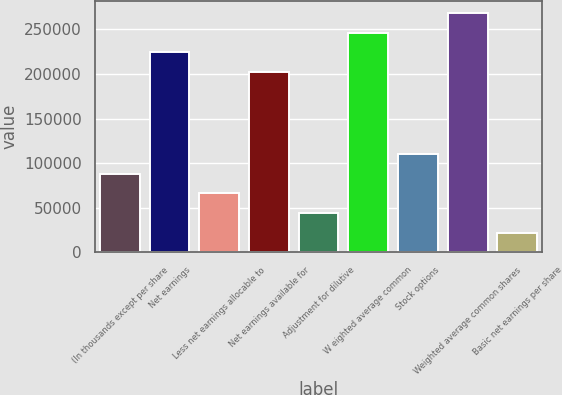Convert chart to OTSL. <chart><loc_0><loc_0><loc_500><loc_500><bar_chart><fcel>(In thousands except per share<fcel>Net earnings<fcel>Less net earnings allocable to<fcel>Net earnings available for<fcel>Adjustment for dilutive<fcel>W eighted average common<fcel>Stock options<fcel>Weighted average common shares<fcel>Basic net earnings per share<nl><fcel>87985.7<fcel>224607<fcel>65989.5<fcel>202611<fcel>43993.3<fcel>246604<fcel>109982<fcel>268600<fcel>21997<nl></chart> 